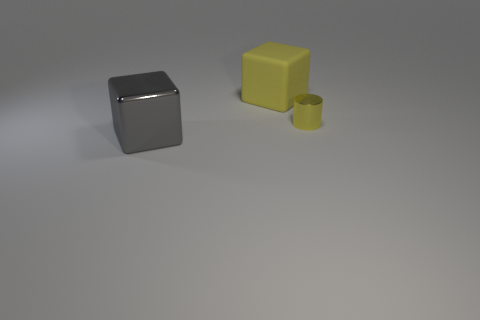Imagine these objects are part of a puzzle, what could be the goal? If these objects were part of a puzzle, the goal might involve fitting the smaller cylinder into a matching hole or stacking the objects according to size or color. 